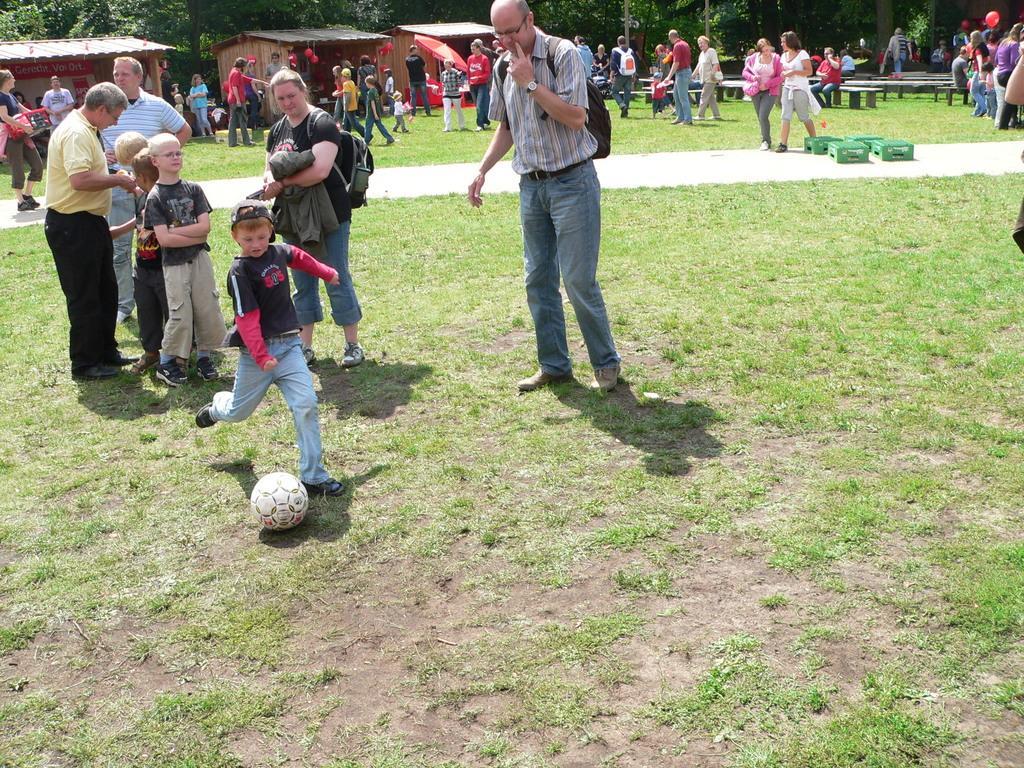How would you summarize this image in a sentence or two? At the bottom of the image there is grass. In the middle of the image few people are standing, walking and holding some bags. Behind them there are some trees, houses and benches. In the middle of the image we can see a ball. 